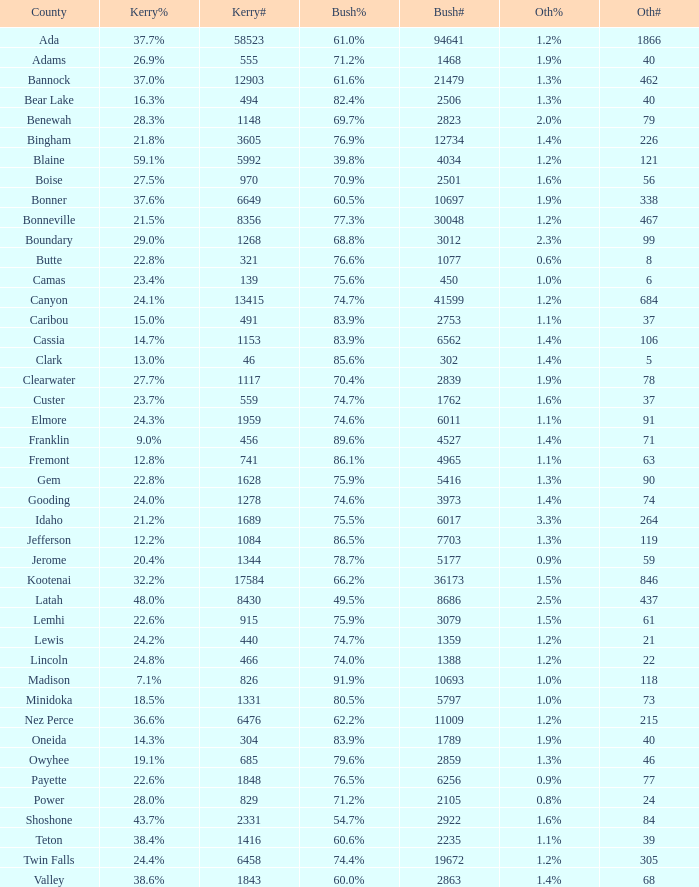What percentage of the people in Bonneville voted for Bush? 77.3%. 